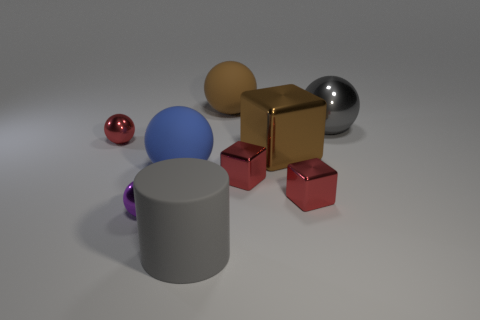Can you describe the lighting in the scene and how it affects the appearance of the different materials? The lighting in the scene appears to be soft and diffused, likely from an overhead source. It creates gentle shadows that reveal the contours of the objects. The metallic and shiny surfaces reflect the light brightly, while the matte surfaces, such as the cylinder, absorb more light, resulting in a less reflective appearance. 